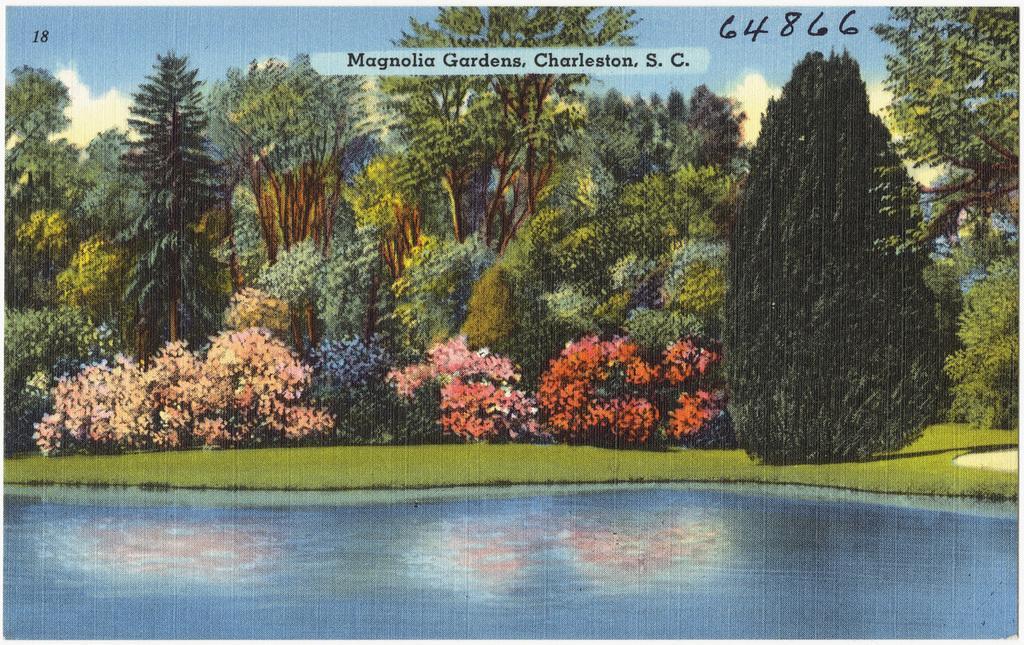Describe this image in one or two sentences. This image is a poster. In this image we can see the water, grass, flower plants and also the trees. We can also see the sky with some clouds. Image also consists of the text and also numbers. 